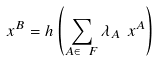<formula> <loc_0><loc_0><loc_500><loc_500>\ x ^ { B } = h \left ( \sum _ { A \in \ F } \lambda _ { A } \ x ^ { A } \right )</formula> 